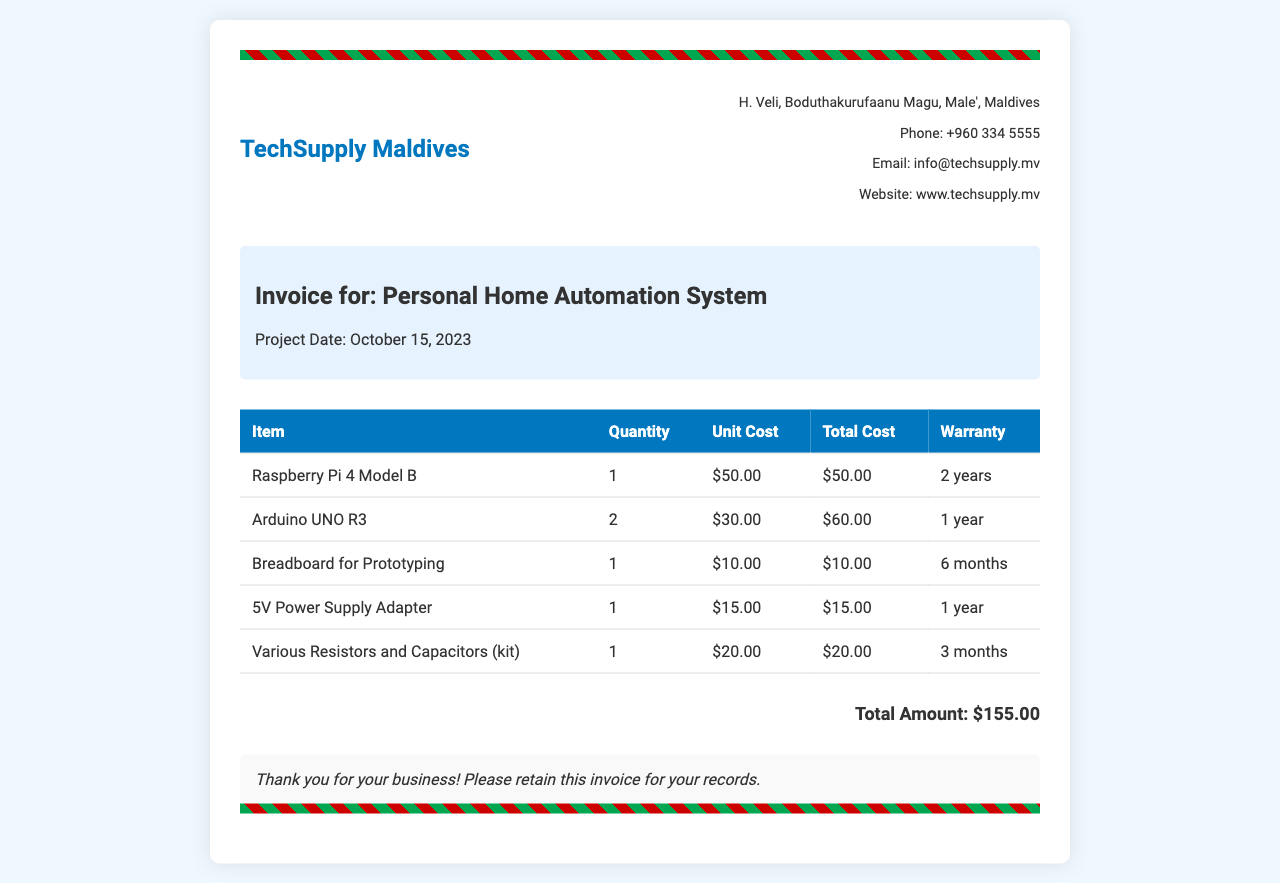What is the vendor's name? The vendor's name is displayed prominently at the top of the invoice next to the logo.
Answer: TechSupply Maldives What is the total amount due? The total amount is calculated at the bottom of the invoice after listing all item costs.
Answer: $155.00 How many Raspberry Pi 4 Model B were purchased? The quantity can be found in the itemized list under the respective item.
Answer: 1 What is the warranty for the Arduino UNO R3? The warranty information is provided next to the item's details in the table.
Answer: 1 year What is the project date? The project date is specified in the project details section of the invoice.
Answer: October 15, 2023 What is the unit cost of the Breadboard for Prototyping? The unit cost can be found in the itemized costs section of the invoice.
Answer: $10.00 Is there a warranty for the Various Resistors and Capacitors (kit)? This information is available in the warranty column of the item's description in the table.
Answer: Yes How many items are listed in the invoice? The number of items can be counted in the table under the item column.
Answer: 5 Where is the vendor located? The vendor's location is provided in the vendor details section on the right side.
Answer: H. Veli, Boduthakurufaanu Magu, Male', Maldives 